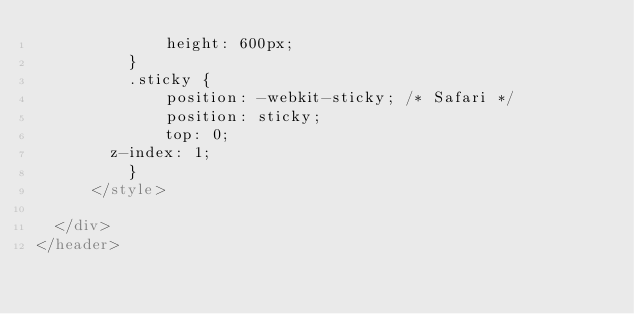<code> <loc_0><loc_0><loc_500><loc_500><_HTML_>              height: 600px;
          }
          .sticky {
              position: -webkit-sticky; /* Safari */
              position: sticky;
              top: 0;
        z-index: 1;
          }
      </style>

  </div>
</header>
</code> 